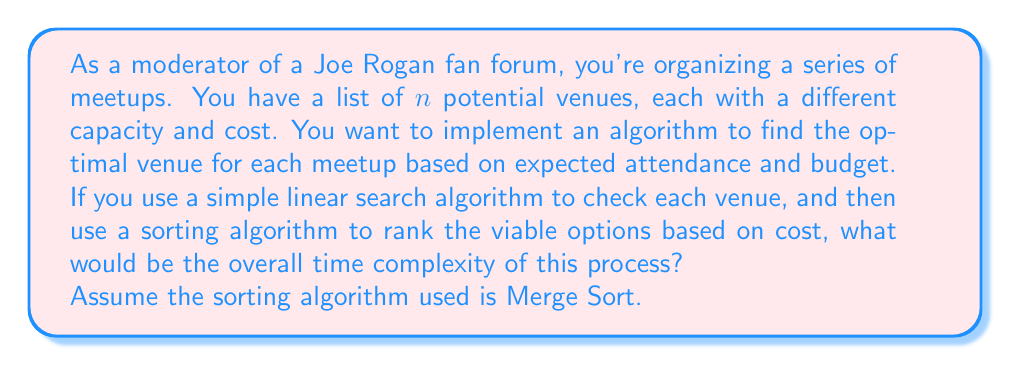Show me your answer to this math problem. To solve this problem, let's break it down into steps:

1. Linear search through venues:
   - This involves checking each venue once.
   - Time complexity: $O(n)$, where $n$ is the number of venues.

2. Sorting viable options:
   - In the worst case, all venues could be viable options.
   - We're using Merge Sort, which has a time complexity of $O(m \log m)$, where $m$ is the number of items to be sorted.
   - In the worst case, $m = n$ (all venues are viable).

Therefore, the overall time complexity is the sum of these two steps:

$$O(n) + O(n \log n)$$

When we have multiple terms, we keep the term with the highest order of growth. In this case, $O(n \log n)$ grows faster than $O(n)$ for large values of $n$.

Thus, the overall time complexity simplifies to:

$$O(n \log n)$$

This means that as the number of venues increases, the time taken by the algorithm will grow in proportion to $n \log n$.
Answer: $O(n \log n)$ 